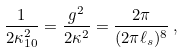<formula> <loc_0><loc_0><loc_500><loc_500>\frac { 1 } { 2 \kappa _ { 1 0 } ^ { 2 } } = \frac { g ^ { 2 } } { 2 \kappa ^ { 2 } } = \frac { 2 \pi } { ( 2 \pi \ell _ { s } ) ^ { 8 } } \, ,</formula> 